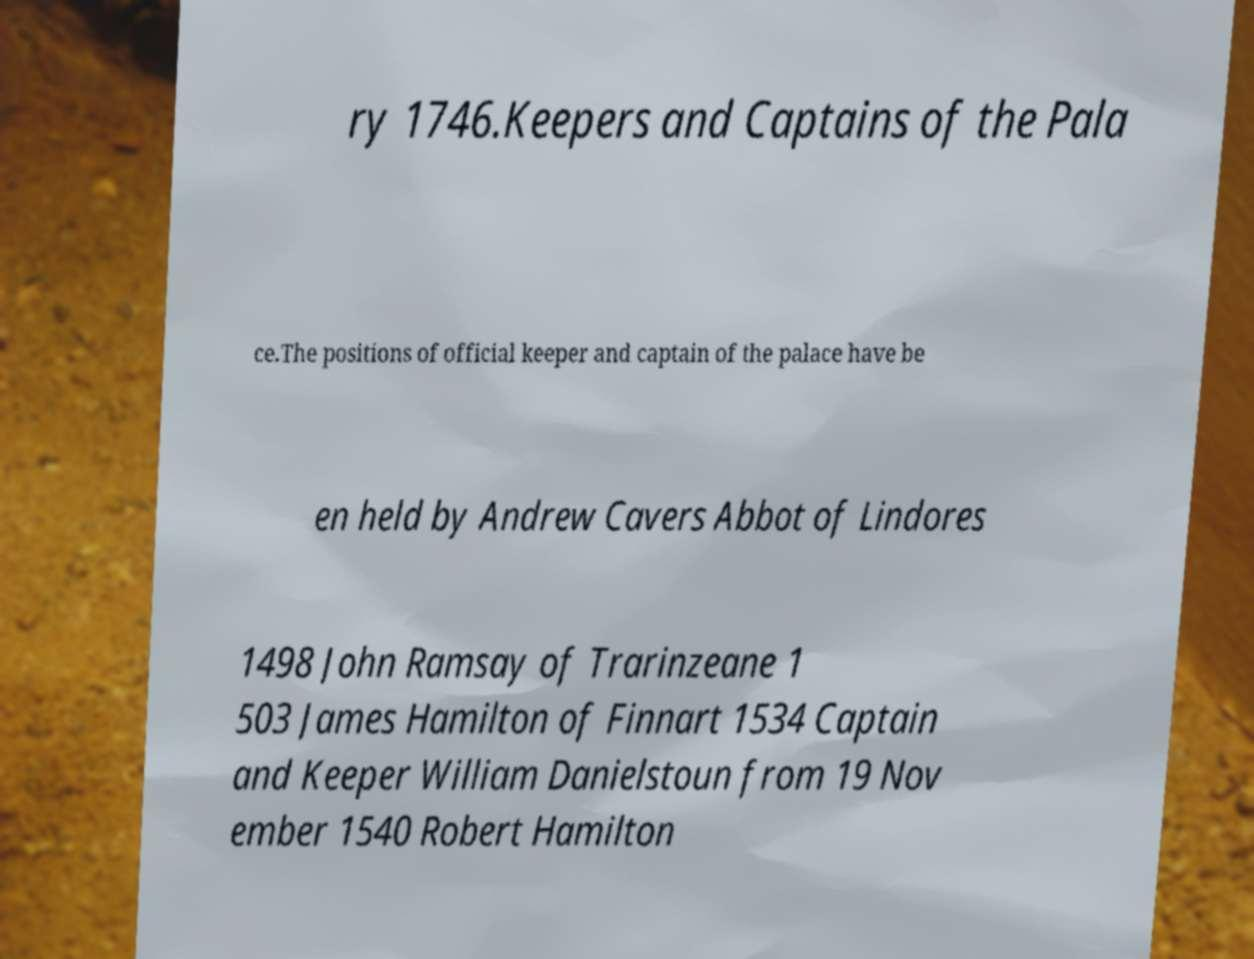Can you read and provide the text displayed in the image?This photo seems to have some interesting text. Can you extract and type it out for me? ry 1746.Keepers and Captains of the Pala ce.The positions of official keeper and captain of the palace have be en held by Andrew Cavers Abbot of Lindores 1498 John Ramsay of Trarinzeane 1 503 James Hamilton of Finnart 1534 Captain and Keeper William Danielstoun from 19 Nov ember 1540 Robert Hamilton 